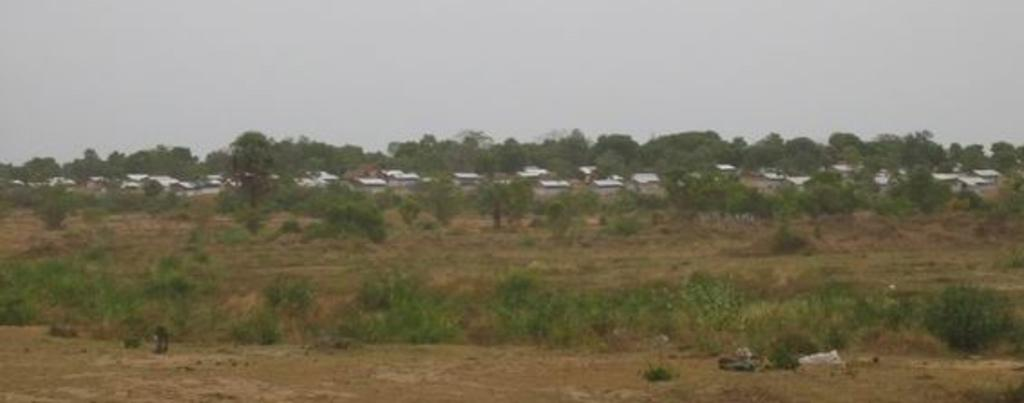What type of vegetation covers the land in the image? The land in the image is covered with dry grass and plants. What structures can be seen behind the land? There are houses behind the land. What type of vegetation surrounds the houses? There are many trees around the houses. Can you see a giraffe walking through the trees in the image? No, there is no giraffe present in the image. 